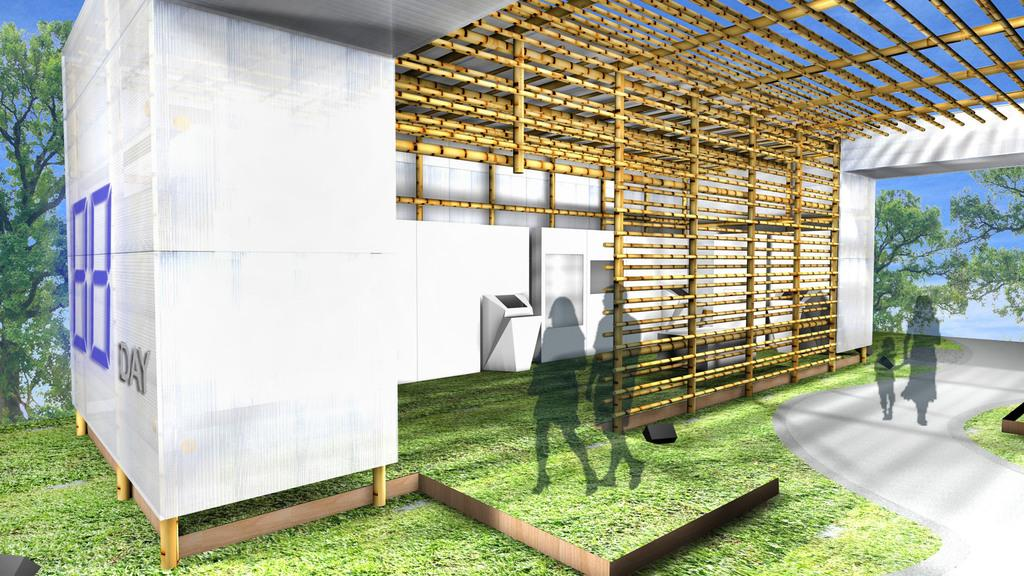What type of structure is present in the image? There is a shed in the image. What can be seen in the background of the image? There are trees in the background of the image. What is the source of the shadows visible in the image? The shadows are likely caused by the sun or other light source, but the specific source is not mentioned in the facts. What is at the bottom of the image? There is a road at the bottom of the image. What is visible on the ground in the image? The ground is visible in the image. What is located at the top of the shed in the image? There is a roof at the top of the image. What type of knife is being used to design the car in the image? There is no knife or car present in the image; it features a shed, trees, shadows, a road, the ground, and a roof. 